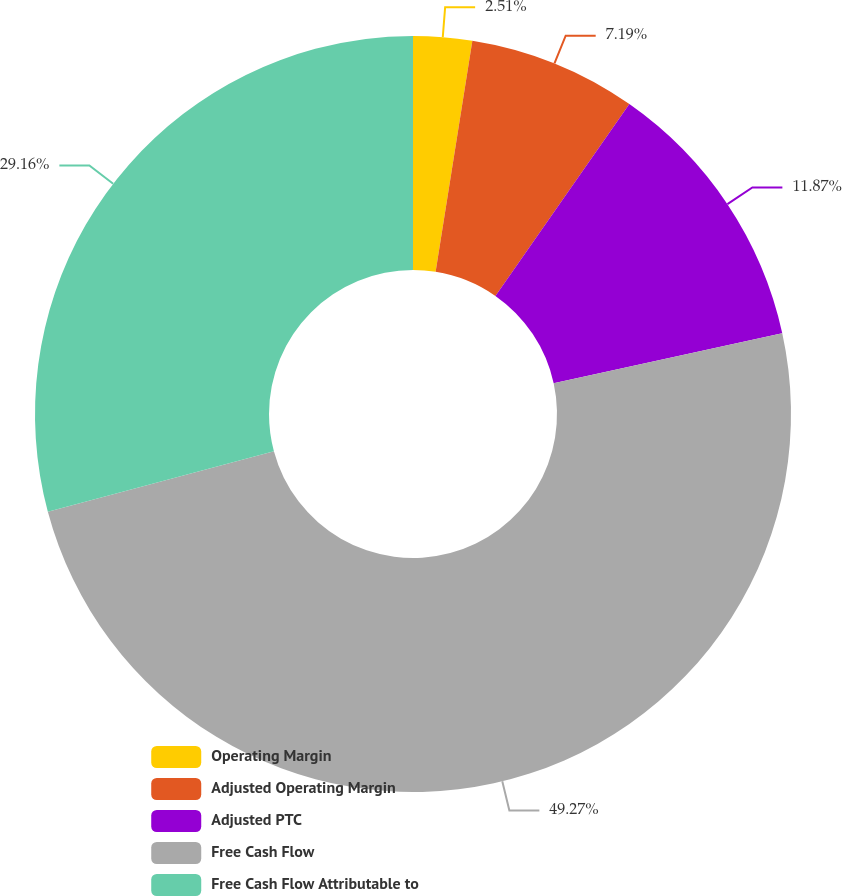Convert chart to OTSL. <chart><loc_0><loc_0><loc_500><loc_500><pie_chart><fcel>Operating Margin<fcel>Adjusted Operating Margin<fcel>Adjusted PTC<fcel>Free Cash Flow<fcel>Free Cash Flow Attributable to<nl><fcel>2.51%<fcel>7.19%<fcel>11.87%<fcel>49.27%<fcel>29.16%<nl></chart> 